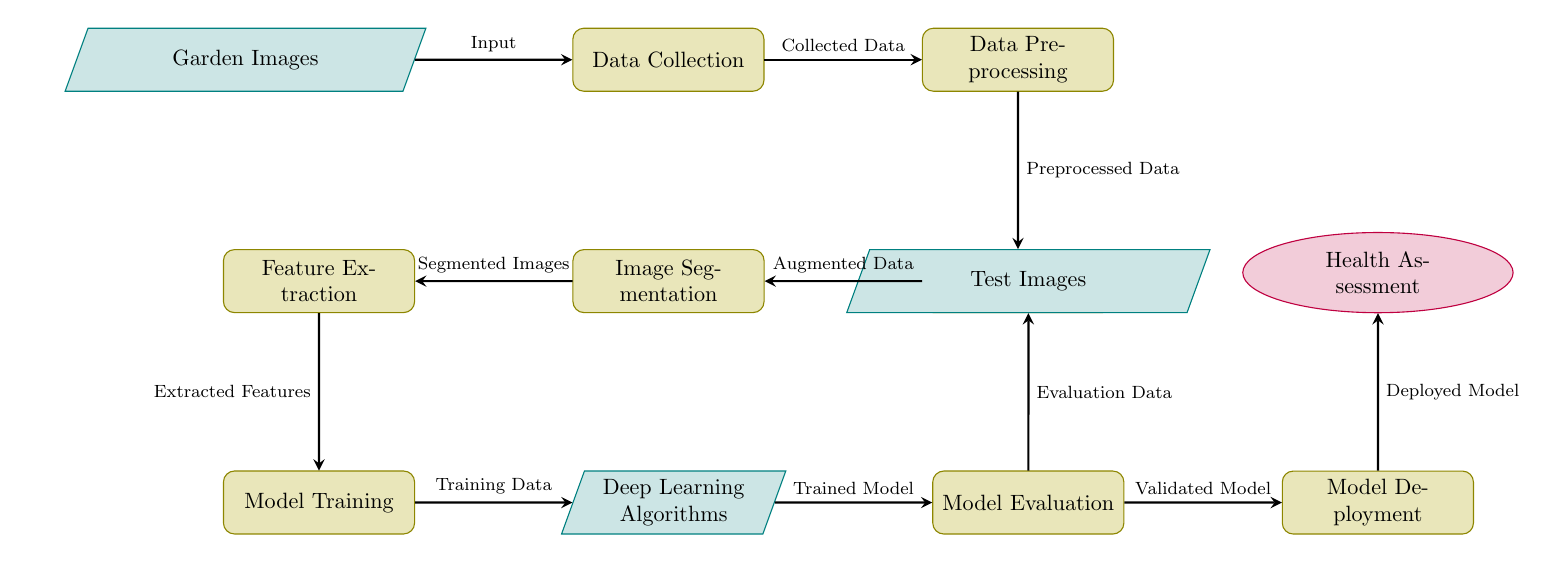What is the first node in the diagram? The first node in the diagram is labeled "Garden Images," which serves as the initial input for the entire process.
Answer: Garden Images How many process nodes are in the diagram? By counting the nodes labeled as processes (rectangles), we find five process nodes: Data Collection, Data Preprocessing, Image Augmentation, Model Training, and Model Evaluation.
Answer: Five What do the arrows in the diagram represent? The arrows in the diagram represent the flow of data between nodes, demonstrating how information moves from one process to another.
Answer: Flow of data What type of node is "Test Images"? "Test Images" is depicted as a data node, characterized by a trapezium shape, indicating it is part of the data input into the model evaluation stage.
Answer: Data What is the relationship between "Model Training" and "Deep Learning Algorithms"? "Model Training" produces the output labeled "Training Data," which serves as input for "Deep Learning Algorithms," establishing a direct connection in the workflow.
Answer: Training Data How many data nodes are there in total? The diagram includes three data nodes: Garden Images, Deep Learning Algorithms, and Test Images.
Answer: Three What is the final output of the diagram? The final output is labeled "Health Assessment," which indicates the end result of the entire process depicted in the diagram.
Answer: Health Assessment What does "Image Segmentation" produce as output? "Image Segmentation" produces "Segmented Images," which are used in subsequent processes to assess plant health.
Answer: Segmented Images What stage comes immediately after "Feature Extraction"? The stage that follows "Feature Extraction" is "Model Training," indicating a sequential flow in the machine learning pipeline.
Answer: Model Training 